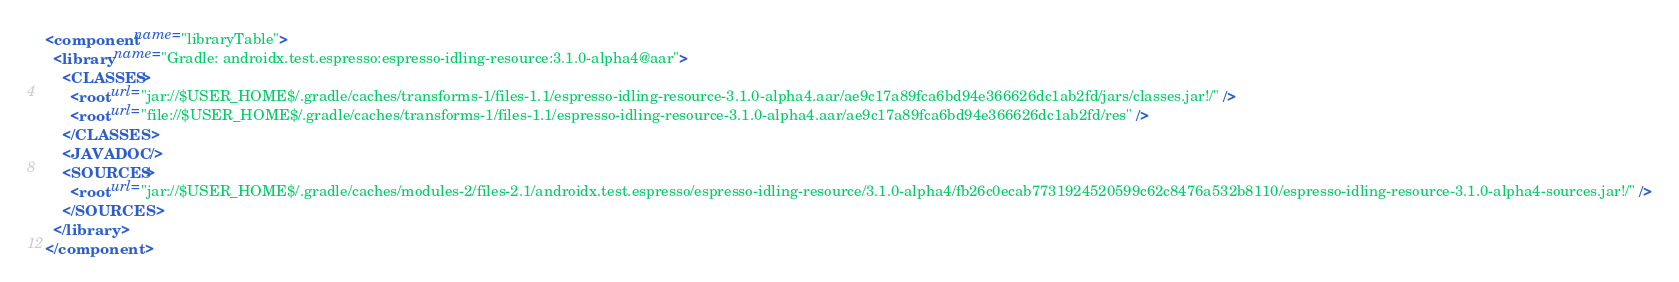<code> <loc_0><loc_0><loc_500><loc_500><_XML_><component name="libraryTable">
  <library name="Gradle: androidx.test.espresso:espresso-idling-resource:3.1.0-alpha4@aar">
    <CLASSES>
      <root url="jar://$USER_HOME$/.gradle/caches/transforms-1/files-1.1/espresso-idling-resource-3.1.0-alpha4.aar/ae9c17a89fca6bd94e366626dc1ab2fd/jars/classes.jar!/" />
      <root url="file://$USER_HOME$/.gradle/caches/transforms-1/files-1.1/espresso-idling-resource-3.1.0-alpha4.aar/ae9c17a89fca6bd94e366626dc1ab2fd/res" />
    </CLASSES>
    <JAVADOC />
    <SOURCES>
      <root url="jar://$USER_HOME$/.gradle/caches/modules-2/files-2.1/androidx.test.espresso/espresso-idling-resource/3.1.0-alpha4/fb26c0ecab7731924520599c62c8476a532b8110/espresso-idling-resource-3.1.0-alpha4-sources.jar!/" />
    </SOURCES>
  </library>
</component></code> 